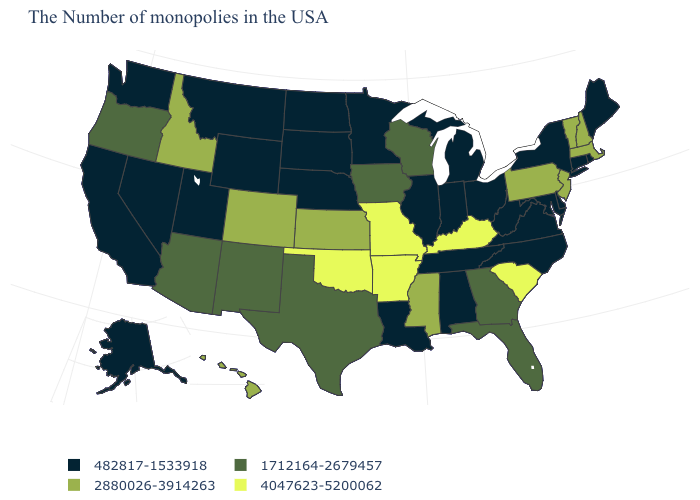What is the value of New Mexico?
Short answer required. 1712164-2679457. What is the value of Maryland?
Concise answer only. 482817-1533918. Does New Jersey have the same value as Oregon?
Write a very short answer. No. Which states have the lowest value in the MidWest?
Keep it brief. Ohio, Michigan, Indiana, Illinois, Minnesota, Nebraska, South Dakota, North Dakota. What is the value of Maine?
Concise answer only. 482817-1533918. Which states have the highest value in the USA?
Quick response, please. South Carolina, Kentucky, Missouri, Arkansas, Oklahoma. What is the value of Wyoming?
Be succinct. 482817-1533918. Does Nevada have a lower value than Kentucky?
Short answer required. Yes. Does Arkansas have the highest value in the USA?
Write a very short answer. Yes. What is the value of Ohio?
Quick response, please. 482817-1533918. Does Delaware have the lowest value in the South?
Be succinct. Yes. Is the legend a continuous bar?
Give a very brief answer. No. What is the highest value in the USA?
Give a very brief answer. 4047623-5200062. Name the states that have a value in the range 2880026-3914263?
Answer briefly. Massachusetts, New Hampshire, Vermont, New Jersey, Pennsylvania, Mississippi, Kansas, Colorado, Idaho, Hawaii. 